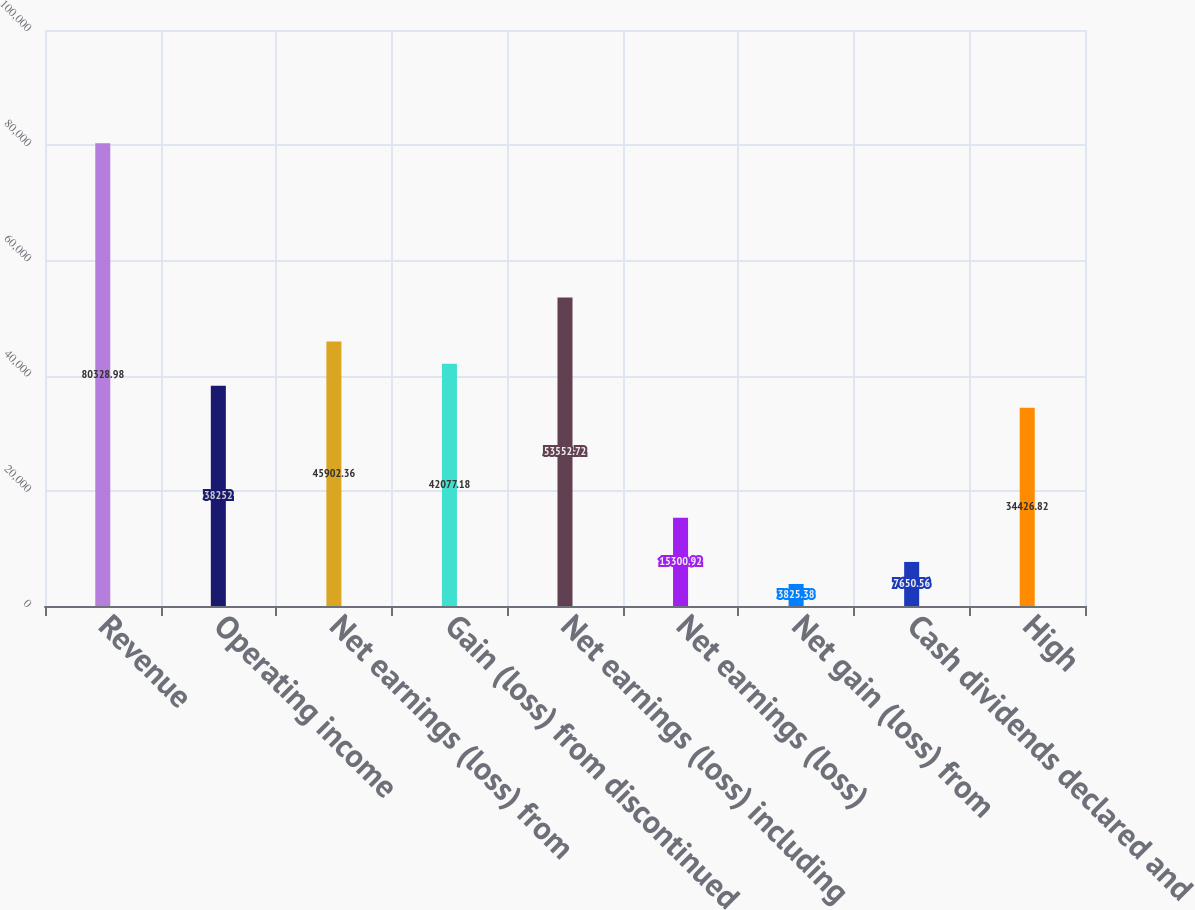Convert chart to OTSL. <chart><loc_0><loc_0><loc_500><loc_500><bar_chart><fcel>Revenue<fcel>Operating income<fcel>Net earnings (loss) from<fcel>Gain (loss) from discontinued<fcel>Net earnings (loss) including<fcel>Net earnings (loss)<fcel>Net gain (loss) from<fcel>Cash dividends declared and<fcel>High<nl><fcel>80329<fcel>38252<fcel>45902.4<fcel>42077.2<fcel>53552.7<fcel>15300.9<fcel>3825.38<fcel>7650.56<fcel>34426.8<nl></chart> 